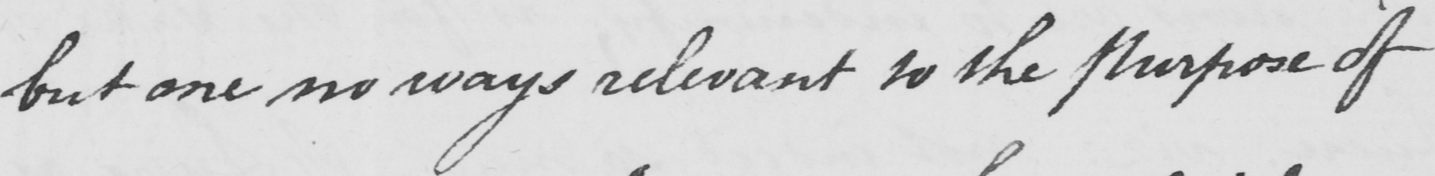Transcribe the text shown in this historical manuscript line. but one no ways relevant to the Purpose of 